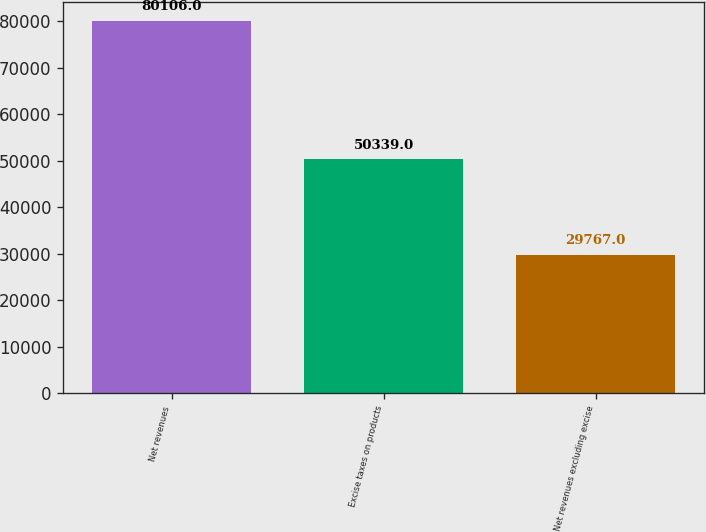<chart> <loc_0><loc_0><loc_500><loc_500><bar_chart><fcel>Net revenues<fcel>Excise taxes on products<fcel>Net revenues excluding excise<nl><fcel>80106<fcel>50339<fcel>29767<nl></chart> 